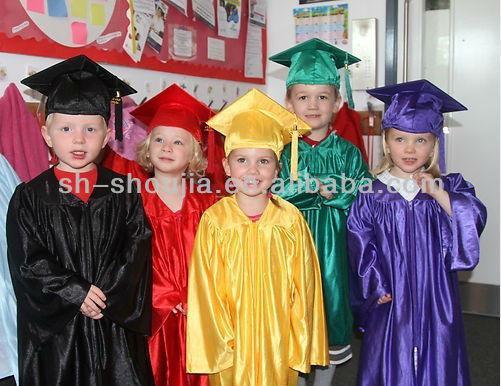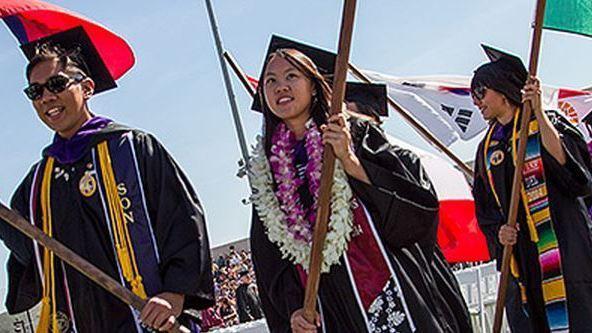The first image is the image on the left, the second image is the image on the right. Assess this claim about the two images: "The left image contains exactly four children modeling four different colored graduation robes with matching hats, and two of them hold rolled white diplomas.". Correct or not? Answer yes or no. No. The first image is the image on the left, the second image is the image on the right. Given the left and right images, does the statement "At least one person is wearing a white gown." hold true? Answer yes or no. No. 